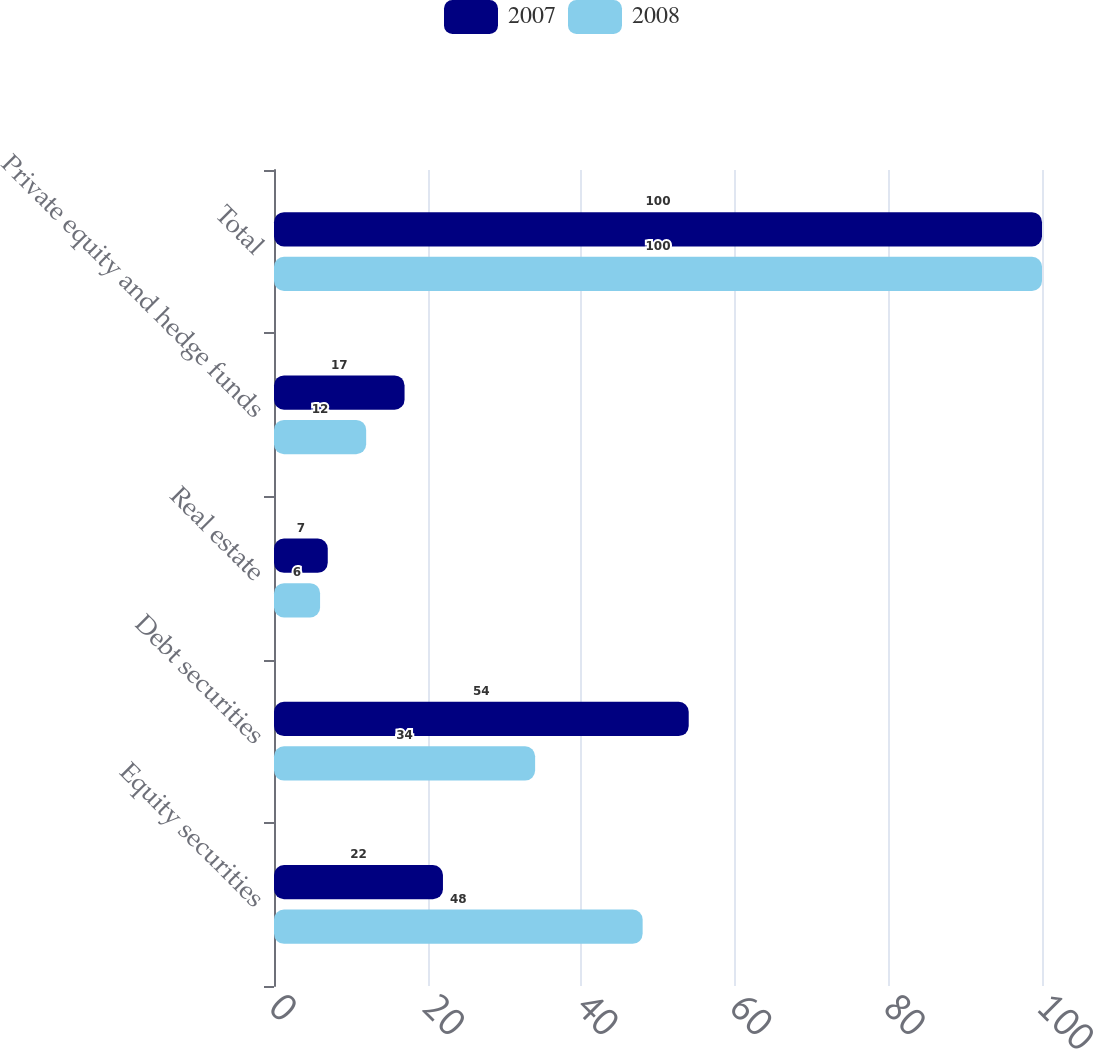Convert chart. <chart><loc_0><loc_0><loc_500><loc_500><stacked_bar_chart><ecel><fcel>Equity securities<fcel>Debt securities<fcel>Real estate<fcel>Private equity and hedge funds<fcel>Total<nl><fcel>2007<fcel>22<fcel>54<fcel>7<fcel>17<fcel>100<nl><fcel>2008<fcel>48<fcel>34<fcel>6<fcel>12<fcel>100<nl></chart> 